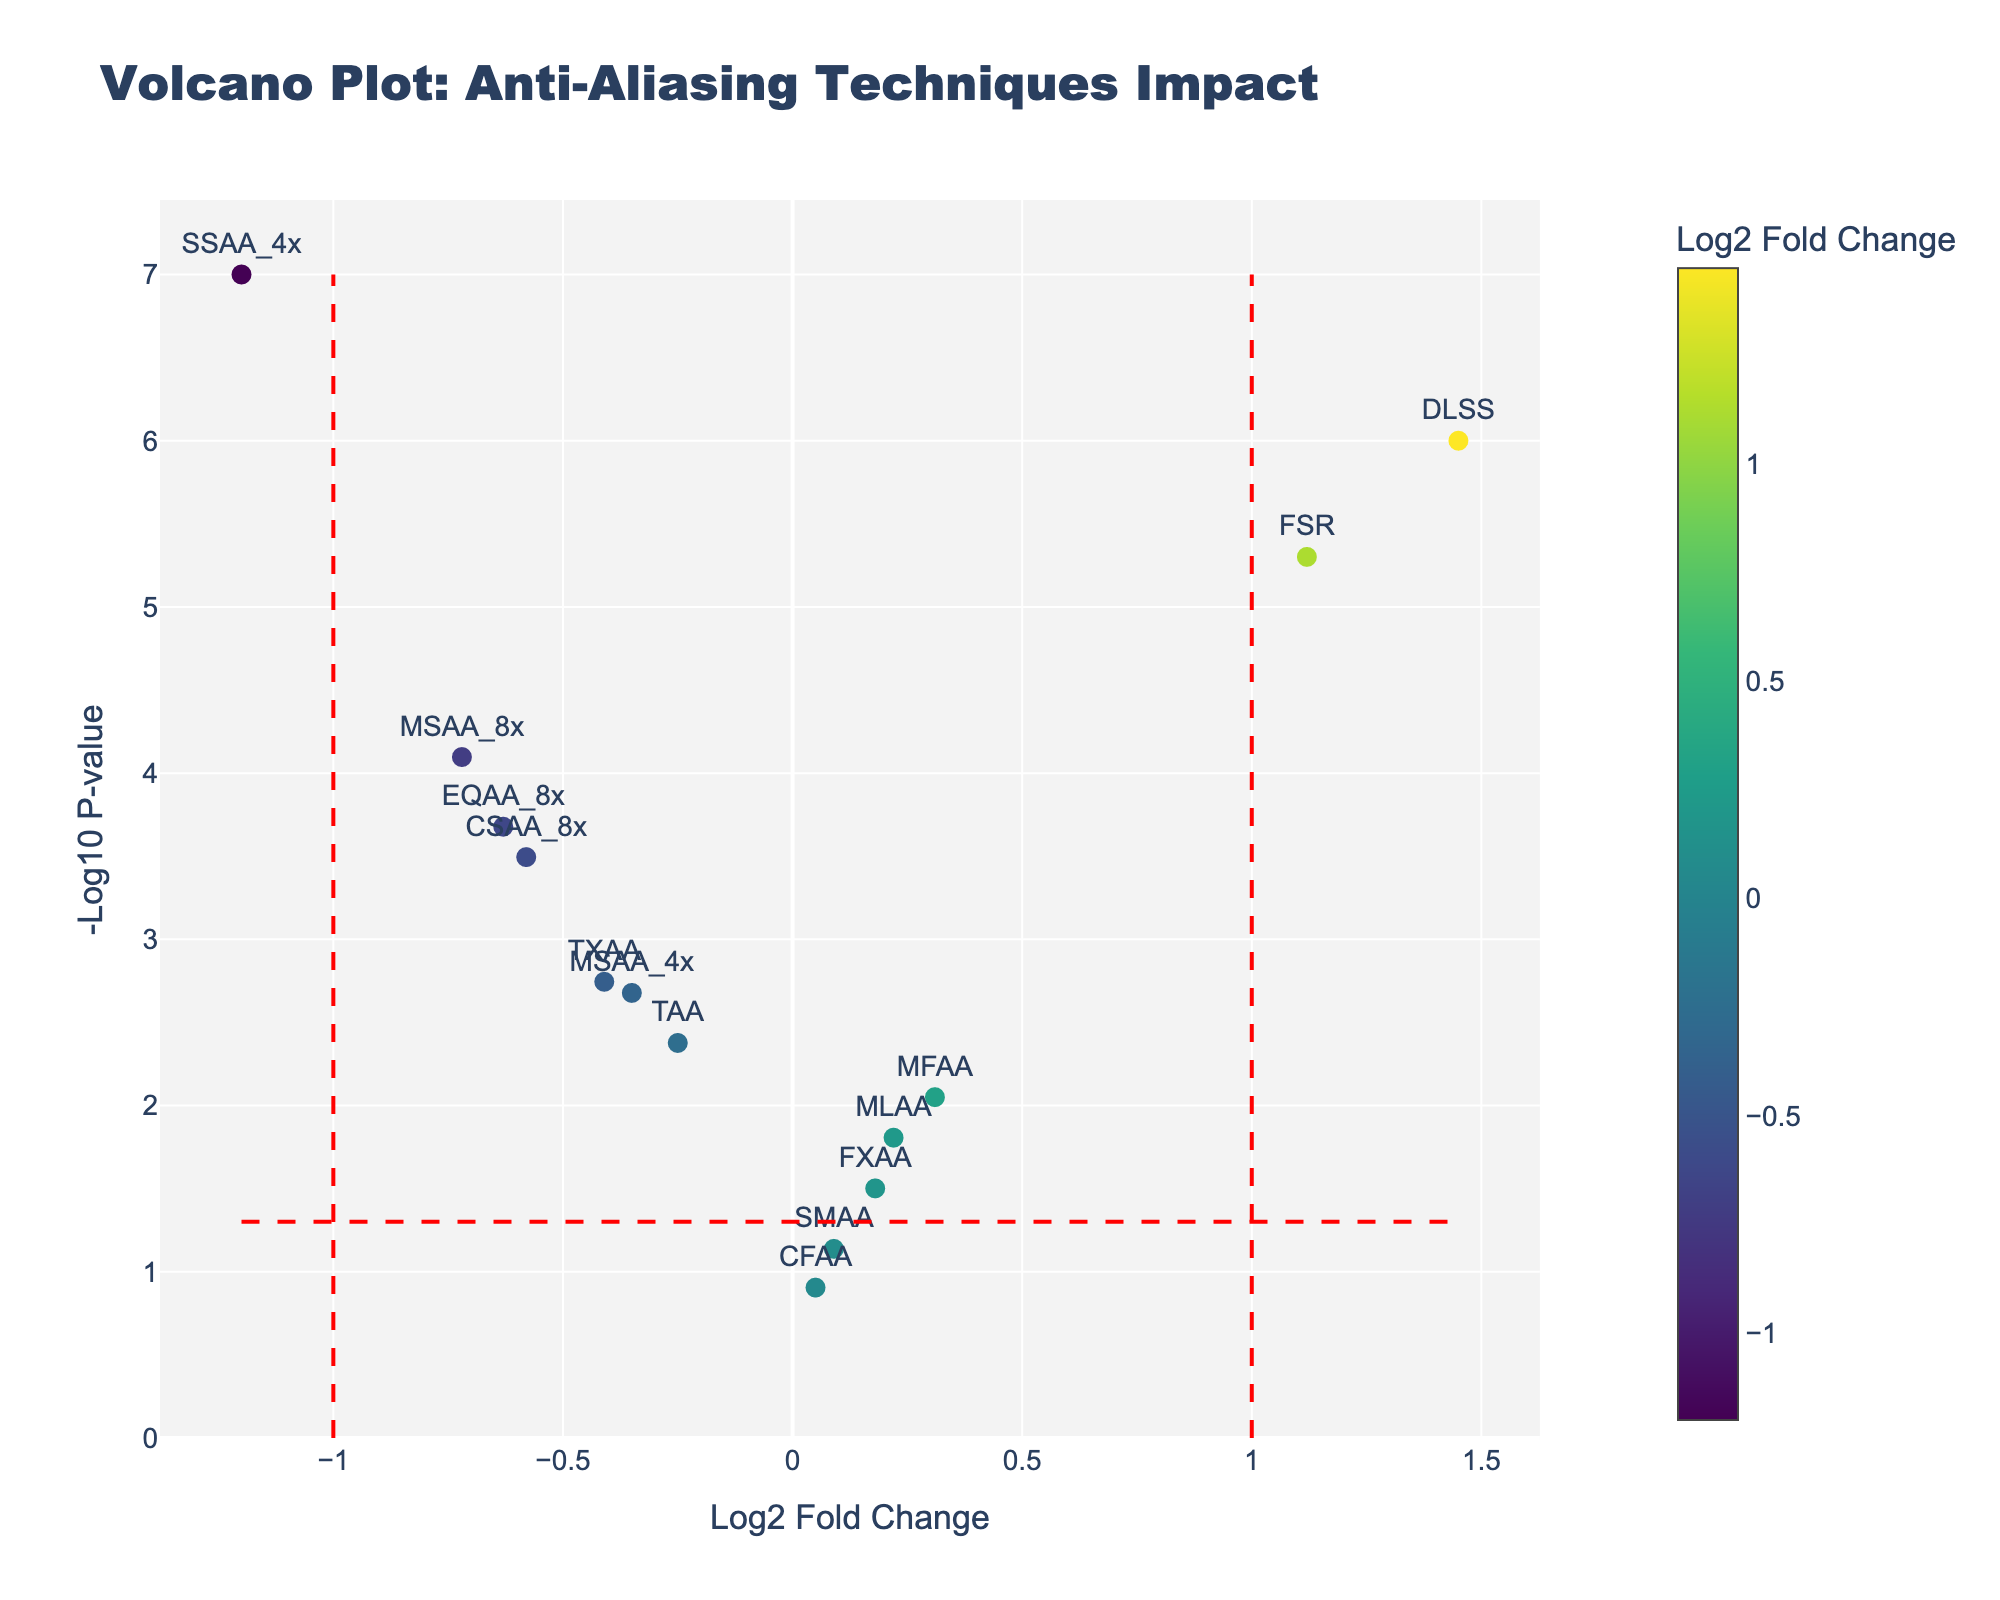How many anti-aliasing techniques were evaluated in the study? The number of data points on the volcano plot represents the number of anti-aliasing techniques. Counting these data points will give the total number of techniques evaluated.
Answer: 14 Which anti-aliasing technique shows the most significant positive impact on performance? The technique with the highest Log2 Fold Change value and the lowest P-value on the plot suggests the most significant positive impact. "DLSS" meets this criterion with a Log2 Fold Change of 1.45 and the lowest P-value.
Answer: DLSS Which technique has the least significant impact on performance, considering both positive and negative directions? Look for the data point closest to the origin (0, 0), as it suggests the smallest Log2 Fold Change and less significance (higher P-value). "CFAA" with a Log2 Fold Change of 0.05 and relatively high P-value fits this description.
Answer: CFAA Are there any techniques that show a log2 fold change greater than 1? If yes, which ones? Check the plot for any data points to the right of the vertical line indicating Log2 Fold Change of 1. "DLSS" and "FSR" show Log2 Fold Changes greater than 1.
Answer: DLSS, FSR Which anti-aliasing technique has the smallest P-value? Identify the data point with the highest -Log10(P-value), which corresponds to the smallest P-value. "SSAA_4x" has the smallest P-value.
Answer: SSAA_4x Which technique has the largest negative Log2 Fold Change, and what is its corresponding P-value? Check for the point farthest left on the plot; "SSAA_4x" has the largest negative Log2 Fold Change of -1.2. Its corresponding P-value is seen from the hover information or data table.
Answer: SSAA_4x, 0.0000001 Is there a correlation between larger Log2 Fold Changes and smaller P-values? If yes, what does it indicate? Generally, observe if data points with larger absolute Log2 Fold Changes have lower P-values, indicating higher significance. This seems to be true, suggesting that more dramatic changes in performance are more statistically significant.
Answer: Yes, indicates higher significance How many techniques have a Log2 Fold Change less than -0.5? Count the data points left of Log2 Fold Change -0.5. The techniques are MSAA_8x, EQAA_8x, and SSAA_4x.
Answer: 3 